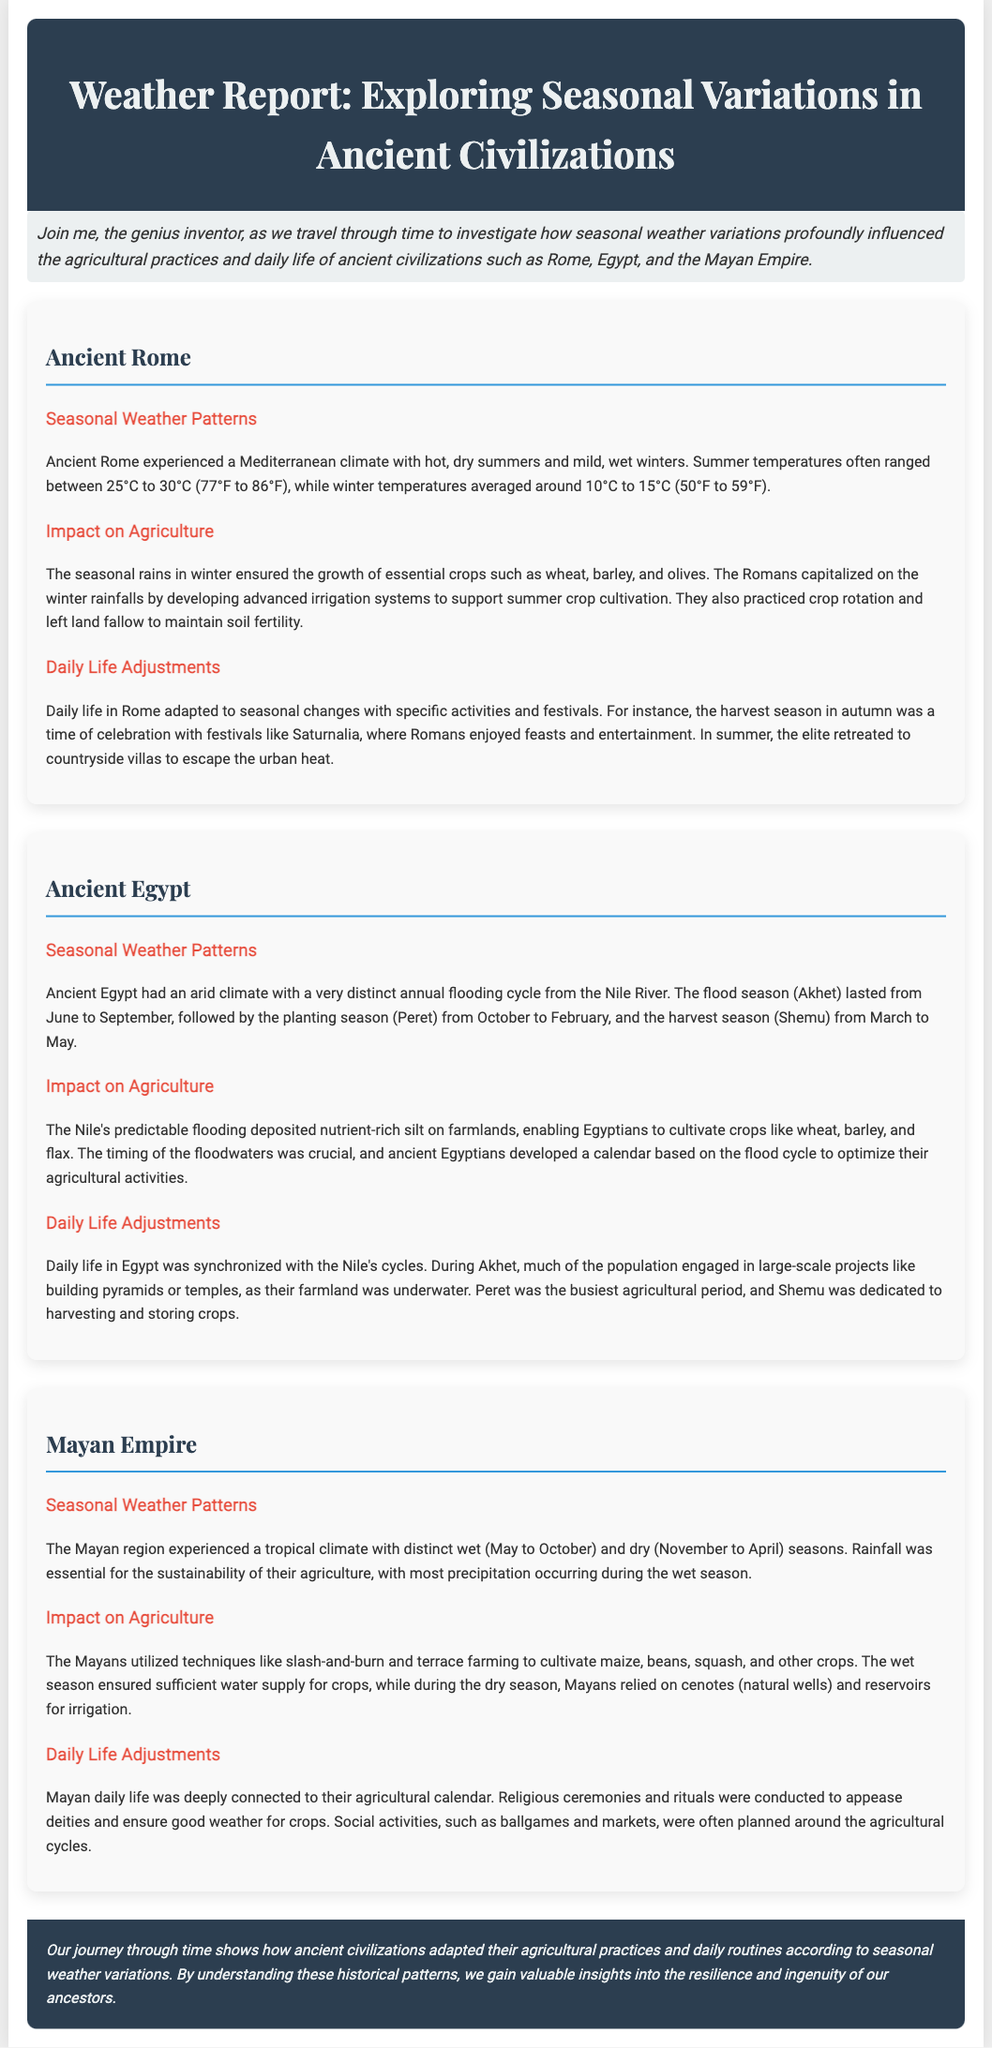What are the three main crops grown in Ancient Rome? The crops mentioned in relation to Ancient Rome are wheat, barley, and olives.
Answer: wheat, barley, olives What is the average winter temperature in Ancient Rome? The document states that winter temperatures averaged around 10°C to 15°C (50°F to 59°F).
Answer: 10°C to 15°C During which season did the Nile flood in Ancient Egypt? The flooding season in Ancient Egypt is referred to as Akhet, which lasted from June to September.
Answer: Akhet What agricultural technique did the Mayans use to manage their crops? The Mayans used techniques like slash-and-burn and terrace farming for agricultural management.
Answer: slash-and-burn and terrace farming What was the agricultural period with the busiest activity in Ancient Egypt? The document indicates that the busiest agricultural period was Peret, from October to February.
Answer: Peret What was the primary reason for daily life adjustments in Ancient Rome? Daily life in Ancient Rome was adapted due to seasonal changes, including specific activities and festivals.
Answer: seasonal changes Which ancient civilization developed a calendar based on the annual flooding of the Nile? The document specifies that ancient Egyptians developed a calendar based on the flood cycle.
Answer: Egyptians What season in the Mayan Empire corresponds to the dry months? The document states that the dry season in the Mayan region lasts from November to April.
Answer: November to April 